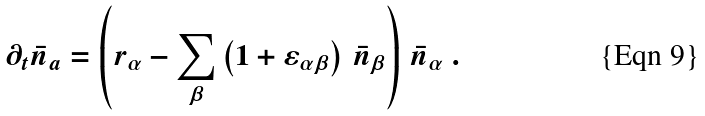Convert formula to latex. <formula><loc_0><loc_0><loc_500><loc_500>\partial _ { t } \bar { n } _ { a } = \left ( r _ { \alpha } - \sum _ { \beta } \left ( 1 + \varepsilon _ { \alpha \beta } \right ) \, \bar { n } _ { \beta } \right ) \, \bar { n } _ { \alpha } \ .</formula> 